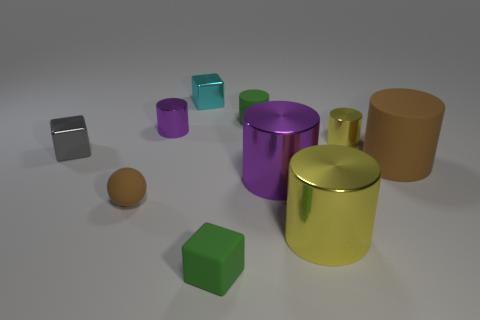There is a matte thing that is the same color as the sphere; what size is it?
Your answer should be compact. Large. There is a small rubber object that is the same color as the tiny matte cylinder; what is its shape?
Ensure brevity in your answer.  Cube. Is there a big cyan cylinder?
Offer a terse response. No. Does the purple object that is on the right side of the small green block have the same shape as the small thing behind the green cylinder?
Keep it short and to the point. No. How many small things are red metal balls or cyan metallic objects?
Provide a succinct answer. 1. What is the shape of the cyan thing that is the same material as the tiny gray thing?
Your answer should be compact. Cube. Do the large purple metallic object and the big yellow thing have the same shape?
Provide a succinct answer. Yes. The tiny sphere has what color?
Provide a succinct answer. Brown. What number of objects are small cylinders or small purple objects?
Provide a short and direct response. 3. Are there fewer brown rubber things in front of the large purple object than green rubber objects?
Make the answer very short. Yes. 